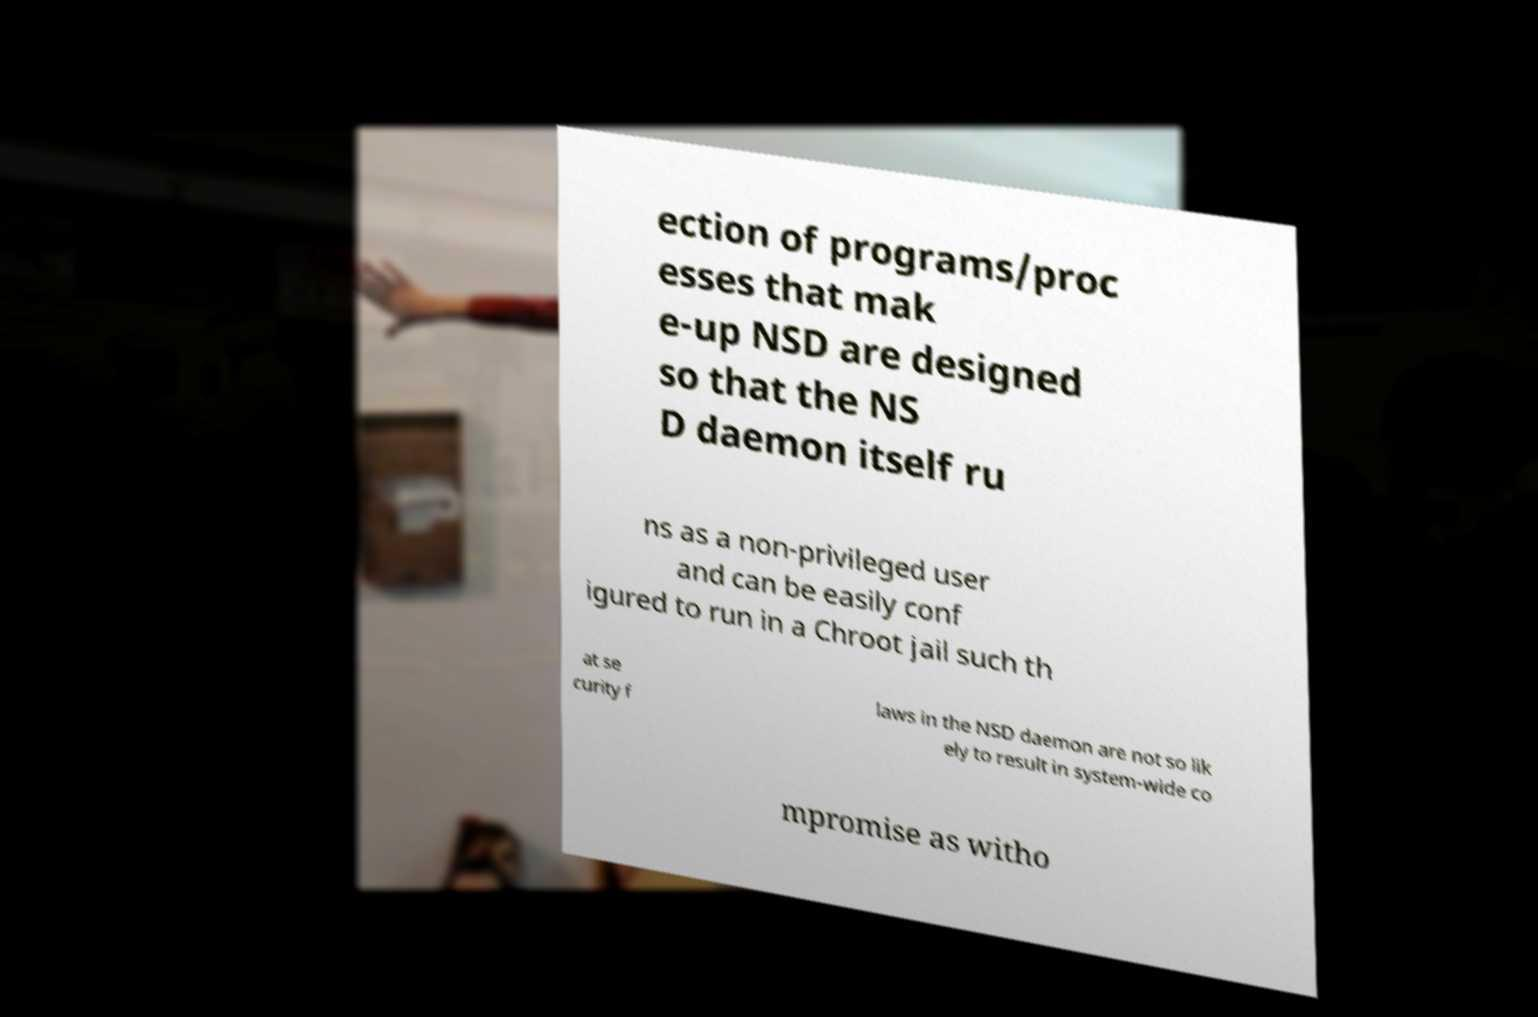For documentation purposes, I need the text within this image transcribed. Could you provide that? ection of programs/proc esses that mak e-up NSD are designed so that the NS D daemon itself ru ns as a non-privileged user and can be easily conf igured to run in a Chroot jail such th at se curity f laws in the NSD daemon are not so lik ely to result in system-wide co mpromise as witho 